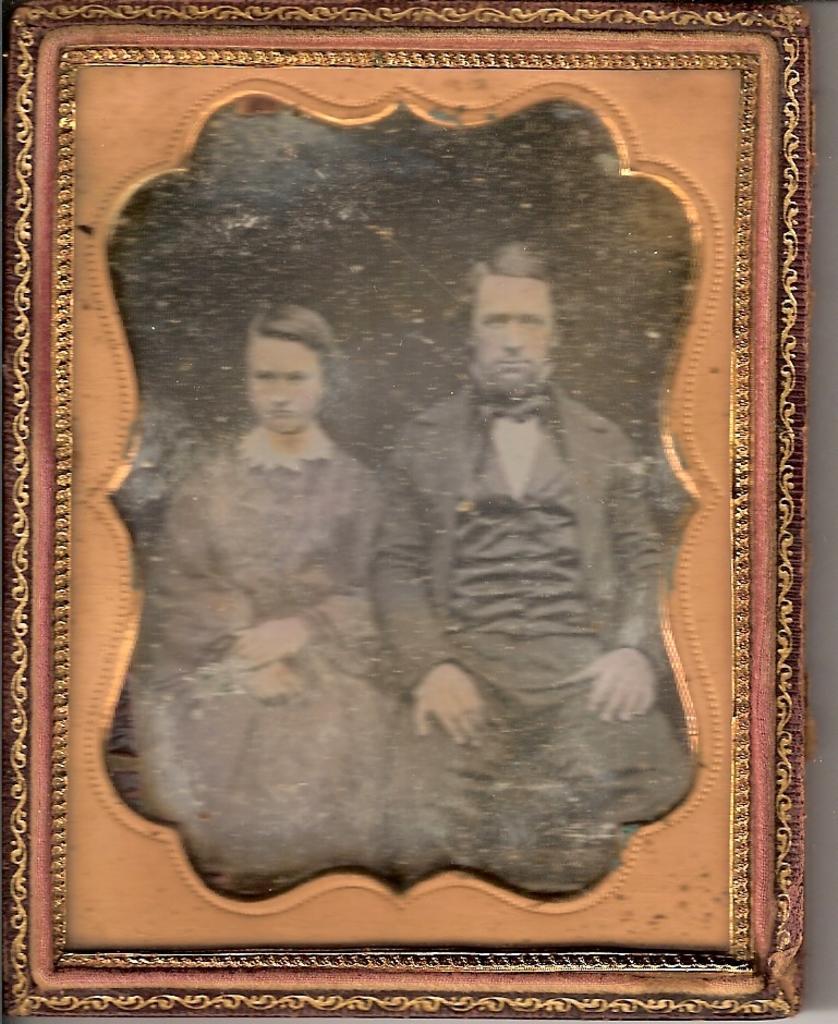Can you describe this image briefly? In this image we can see a photo frame of a person and a woman. 